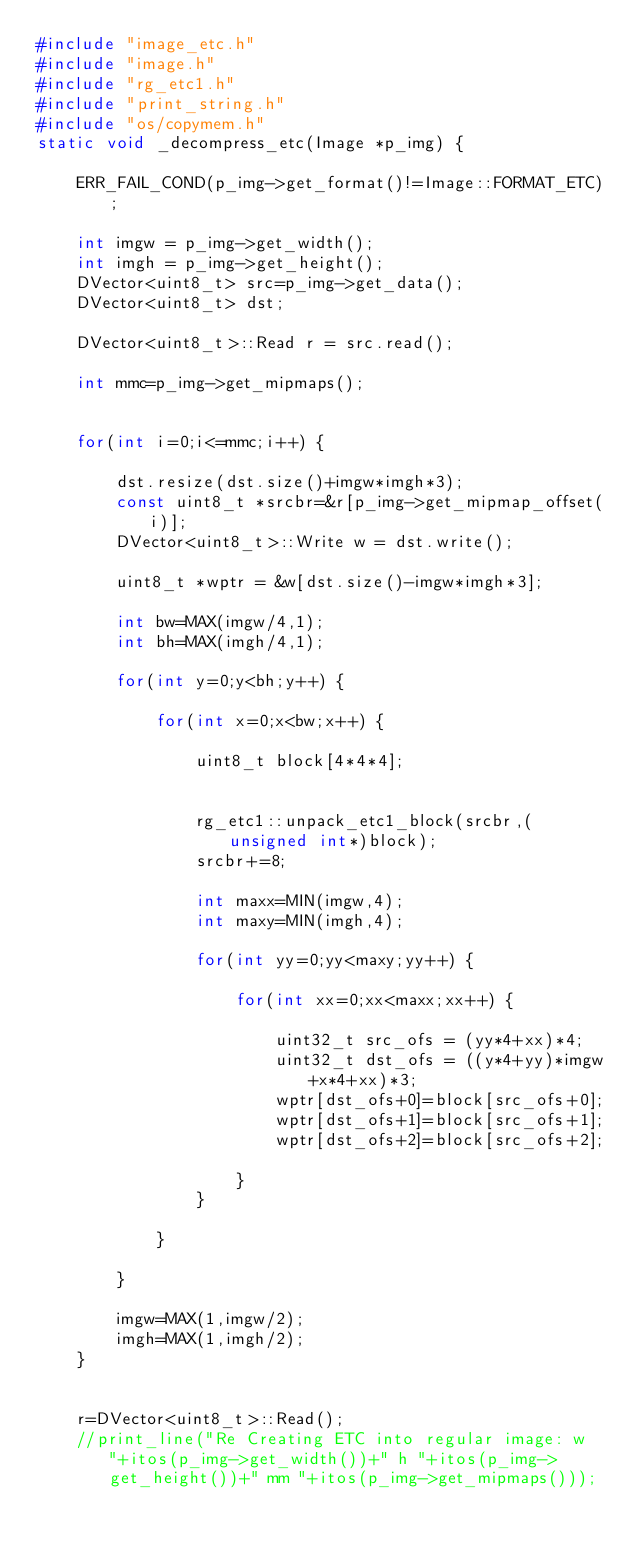<code> <loc_0><loc_0><loc_500><loc_500><_C++_>#include "image_etc.h"
#include "image.h"
#include "rg_etc1.h"
#include "print_string.h"
#include "os/copymem.h"
static void _decompress_etc(Image *p_img) {

	ERR_FAIL_COND(p_img->get_format()!=Image::FORMAT_ETC);

	int imgw = p_img->get_width();
	int imgh = p_img->get_height();
	DVector<uint8_t> src=p_img->get_data();
	DVector<uint8_t> dst;

	DVector<uint8_t>::Read r = src.read();

	int mmc=p_img->get_mipmaps();


	for(int i=0;i<=mmc;i++) {

		dst.resize(dst.size()+imgw*imgh*3);
		const uint8_t *srcbr=&r[p_img->get_mipmap_offset(i)];
		DVector<uint8_t>::Write w = dst.write();

		uint8_t *wptr = &w[dst.size()-imgw*imgh*3];

		int bw=MAX(imgw/4,1);
		int bh=MAX(imgh/4,1);

		for(int y=0;y<bh;y++) {

			for(int x=0;x<bw;x++) {

				uint8_t block[4*4*4];


				rg_etc1::unpack_etc1_block(srcbr,(unsigned int*)block);
				srcbr+=8;

				int maxx=MIN(imgw,4);
				int maxy=MIN(imgh,4);

				for(int yy=0;yy<maxy;yy++) {

					for(int xx=0;xx<maxx;xx++) {

						uint32_t src_ofs = (yy*4+xx)*4;
						uint32_t dst_ofs = ((y*4+yy)*imgw+x*4+xx)*3;
						wptr[dst_ofs+0]=block[src_ofs+0];
						wptr[dst_ofs+1]=block[src_ofs+1];
						wptr[dst_ofs+2]=block[src_ofs+2];

					}
				}

			}

		}

		imgw=MAX(1,imgw/2);
		imgh=MAX(1,imgh/2);
	}


	r=DVector<uint8_t>::Read();
	//print_line("Re Creating ETC into regular image: w "+itos(p_img->get_width())+" h "+itos(p_img->get_height())+" mm "+itos(p_img->get_mipmaps()));</code> 